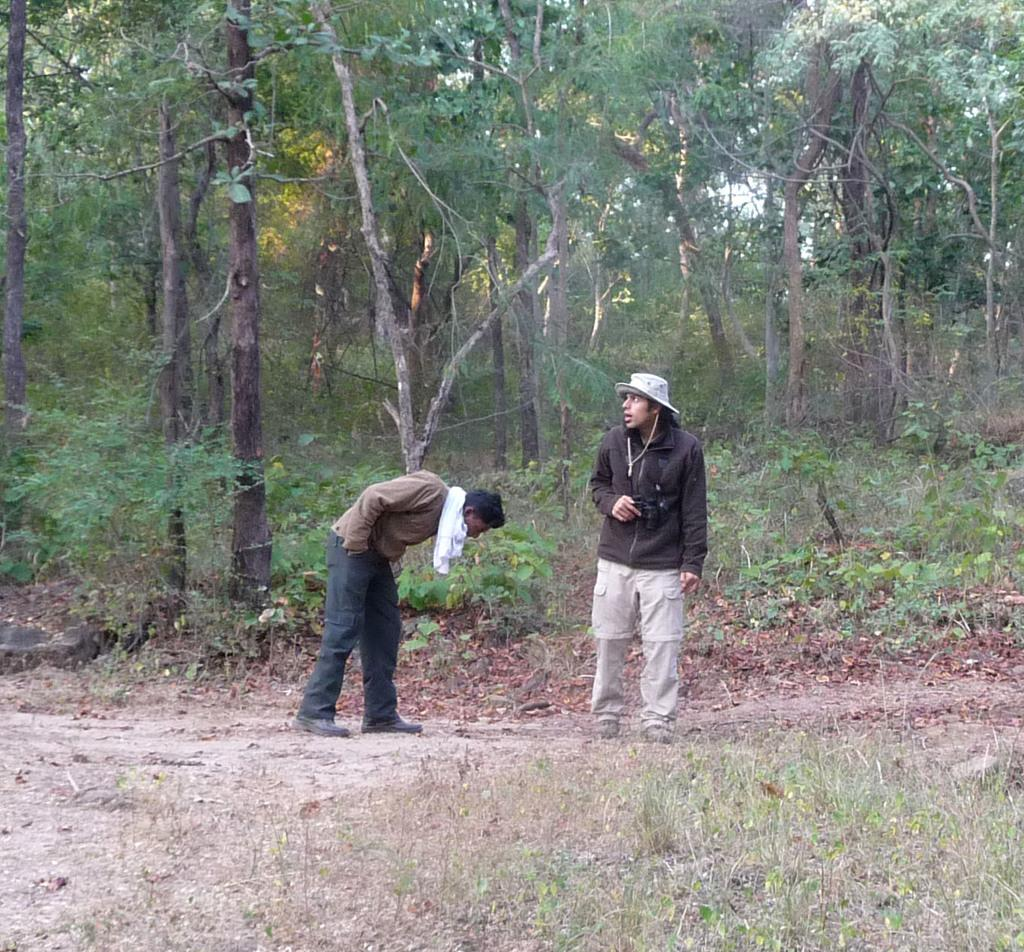How many people are in the image? There are two men in the image. What can be seen in the background behind the men? There are plenty of trees behind the men. What is the ground like in front of the men? There is dry grass in front of the men. What type of mint can be seen growing in the image? There is no mint present in the image; it features two men and a background of trees. 